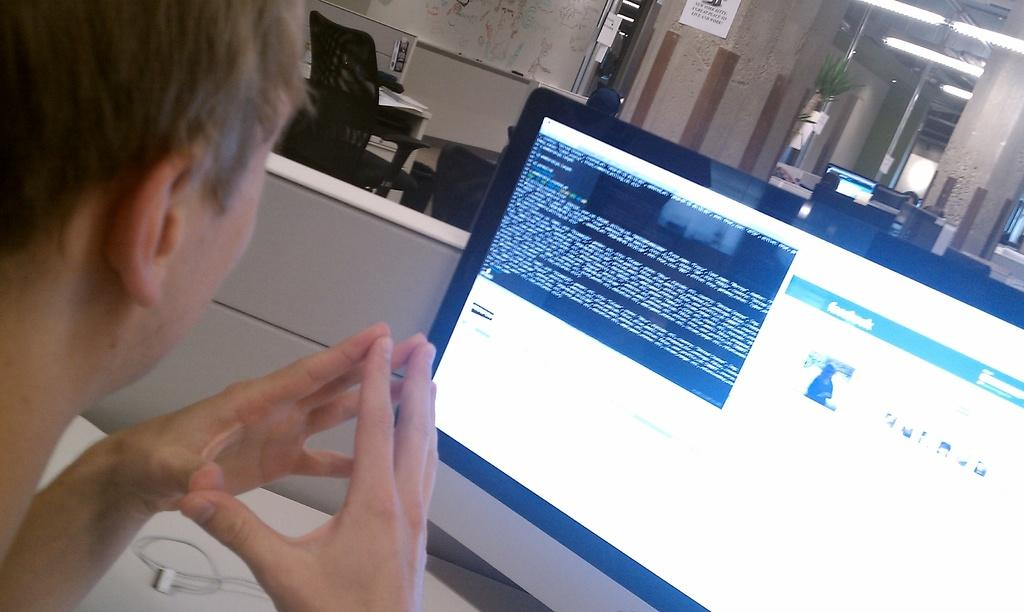What is the man in the foreground of the image doing? The man is sitting near a computer in the foreground of the image. What can be seen in the background of the image? In the background of the image, there are chairs, tables, a wall, a map, lights, and plants. Can you describe the setting where the man is located? The man is in a room with chairs, tables, a wall, a map, lights, and plants in the background. What type of kitty is sitting on the man's lap in the image? There is no kitty present in the image; the man is sitting near a computer without any animals. 